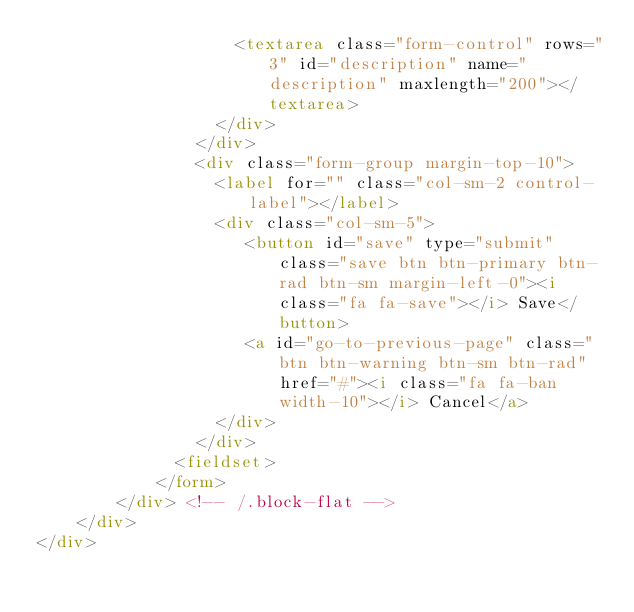<code> <loc_0><loc_0><loc_500><loc_500><_HTML_>                    <textarea class="form-control" rows="3" id="description" name="description" maxlength="200"></textarea>
                  </div>
                </div>
                <div class="form-group margin-top-10">
                  <label for="" class="col-sm-2 control-label"></label>
                  <div class="col-sm-5">
                     <button id="save" type="submit" class="save btn btn-primary btn-rad btn-sm margin-left-0"><i class="fa fa-save"></i> Save</button>
                     <a id="go-to-previous-page" class="btn btn-warning btn-sm btn-rad" href="#"><i class="fa fa-ban width-10"></i> Cancel</a>
                  </div>
                </div>
              <fieldset>
            </form>
        </div> <!-- /.block-flat -->
    </div>
</div></code> 